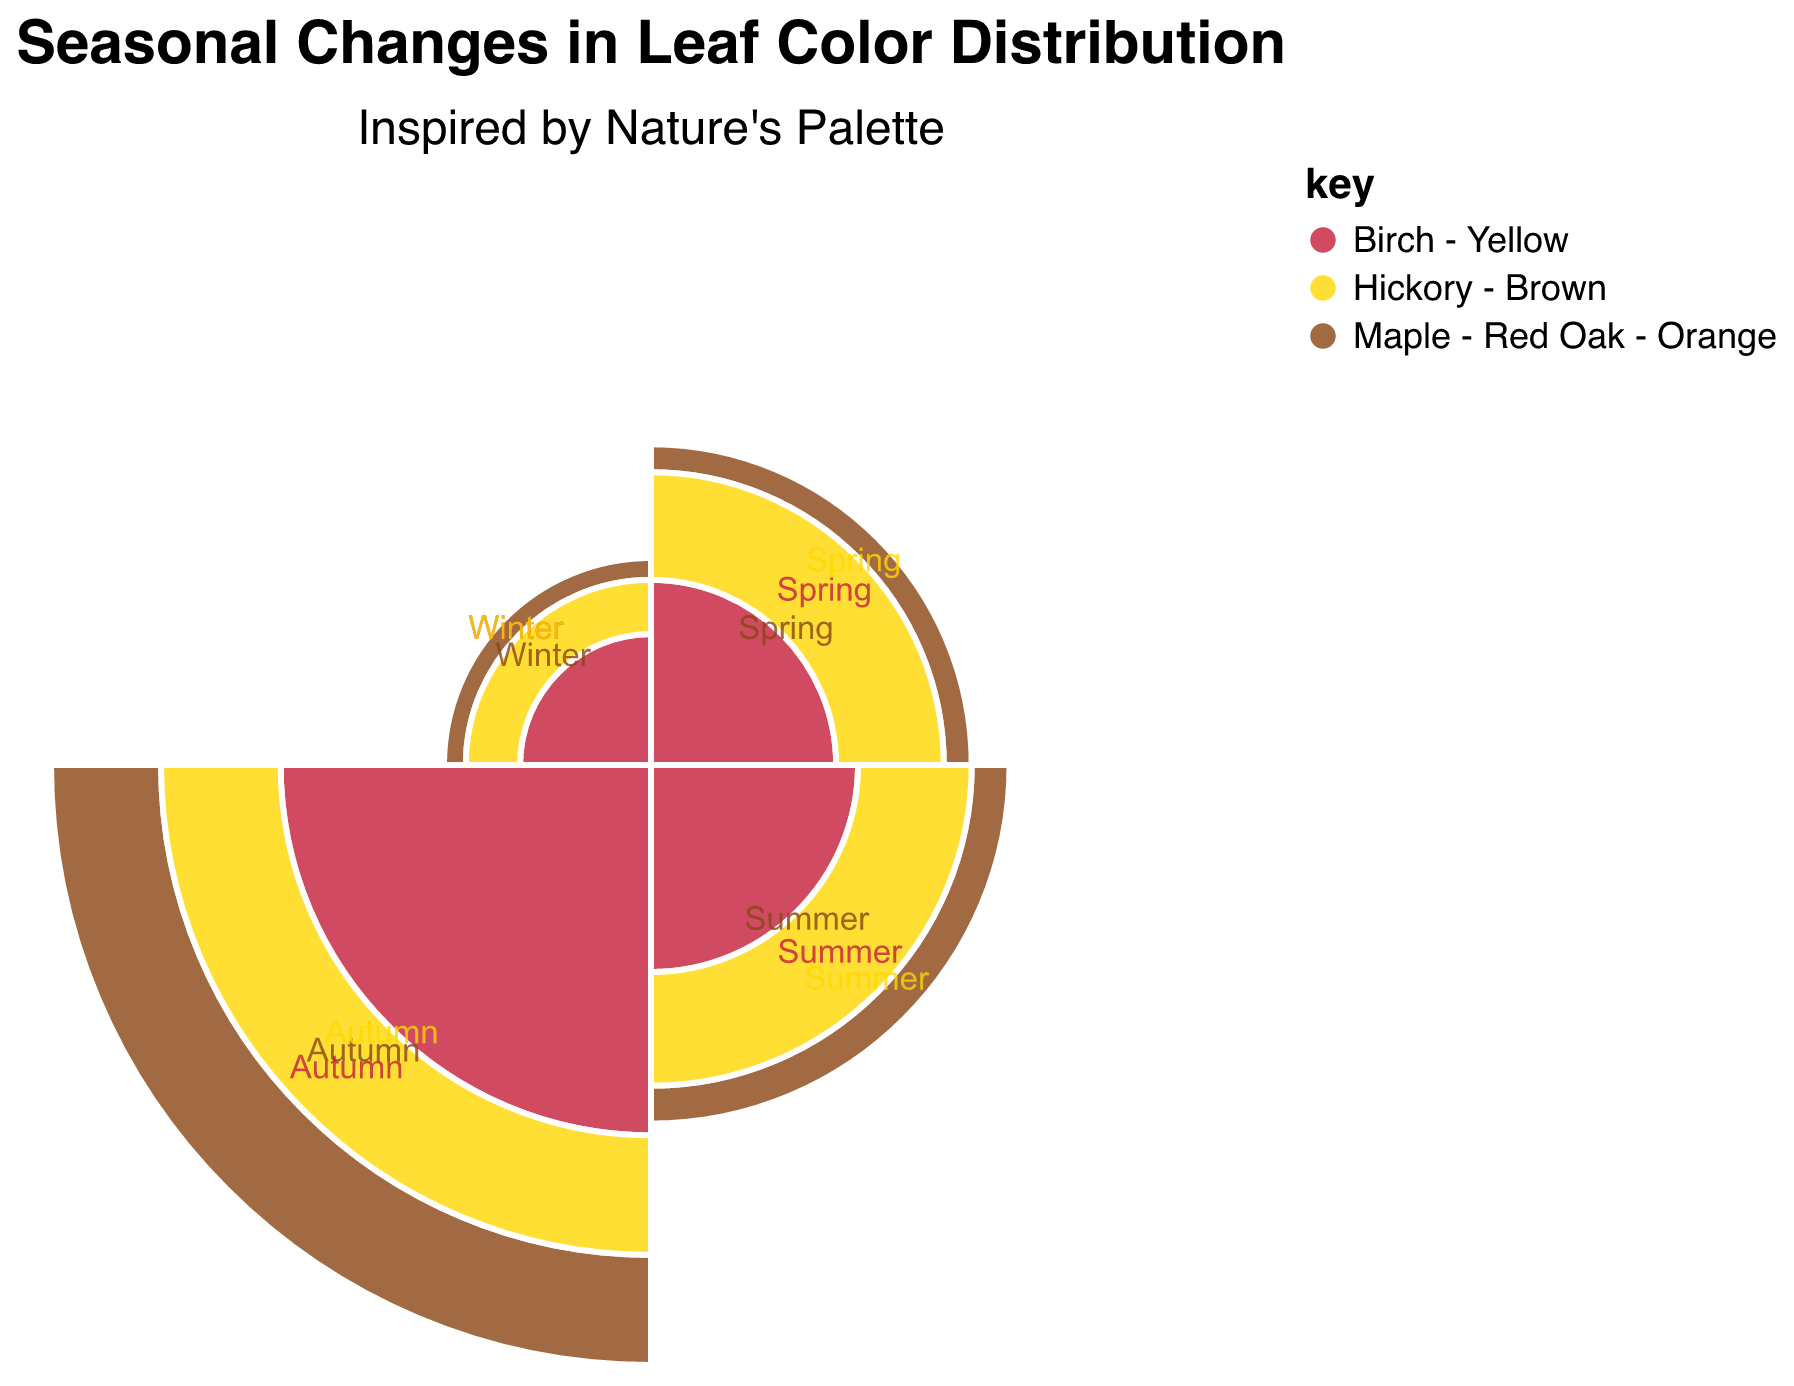What is the title of the chart? The title of the chart can be found at the top of the figure.
Answer: Seasonal Changes in Leaf Color Distribution Which season has the highest amount of 'Birch - Yellow' leaves? Look at the segment corresponding to 'Birch - Yellow' and compare the sizes across the seasons.
Answer: Autumn How much more 'Maple - Red Oak - Orange' leaves are there in Autumn compared to Winter? Look at the values for 'Maple - Red Oak - Orange' in Autumn and Winter: 70 in Autumn and 5 in Winter. Then calculate the difference: 70 - 5.
Answer: 65 In which season do 'Hickory - Brown' leaves decrease the most compared to the previous season? Compare the values in consecutive seasons for 'Hickory - Brown': 30 in Spring to 35 in Summer (increase), 35 in Summer to 60 in Autumn (increase), 60 in Autumn to 10 in Winter (decrease). The largest decrease happens between Autumn and Winter.
Answer: Winter What is the total number of 'Birch - Yellow' leaves across all seasons? Sum up the values for 'Birch - Yellow': 20 (Spring) + 25 (Summer) + 80 (Autumn) + 10 (Winter).
Answer: 135 Which color category shows a noticeable peak during Autumn? Observe the chart and find the category with the largest segment in Autumn.
Answer: Birch - Yellow How does the distribution of 'Maple - Red Oak - Orange' leaves in Spring compare to that in Summer? Look at the values for 'Maple - Red Oak - Orange' in both Spring and Summer: 10 in Spring and 15 in Summer. Summer has more 'Maple - Red Oak - Orange' leaves.
Answer: Summer What is the average number of leaves per season for 'Hickory - Brown'? Calculate the average for 'Hickory - Brown' by summing the values and dividing by the number of seasons: (30 + 35 + 60 + 10) / 4.
Answer: 33.75 Which season has the lowest total leaf count across all color categories? Sum the values for all categories in each season and compare: Spring total = 10 + 20 + 30 (60), Summer total = 15 + 25 + 35 (75), Autumn total = 70 + 80 + 60 (210), Winter total = 5 + 10 + 10 (25).
Answer: Winter 